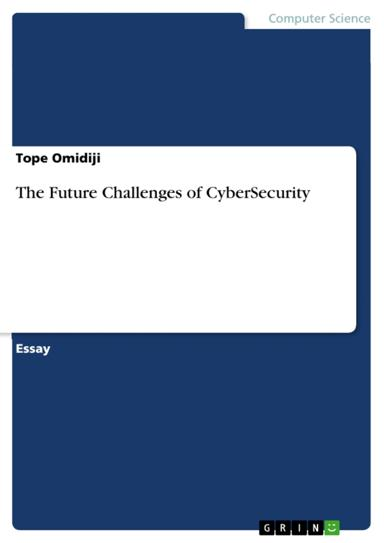What is the title of the essay mentioned in the image? The title of the essay is "The Future Challenges of CyberSecurity" by Tope Omidiji. In which field is the essay mentioned in the image? The essay is in the field of Computer Science. 